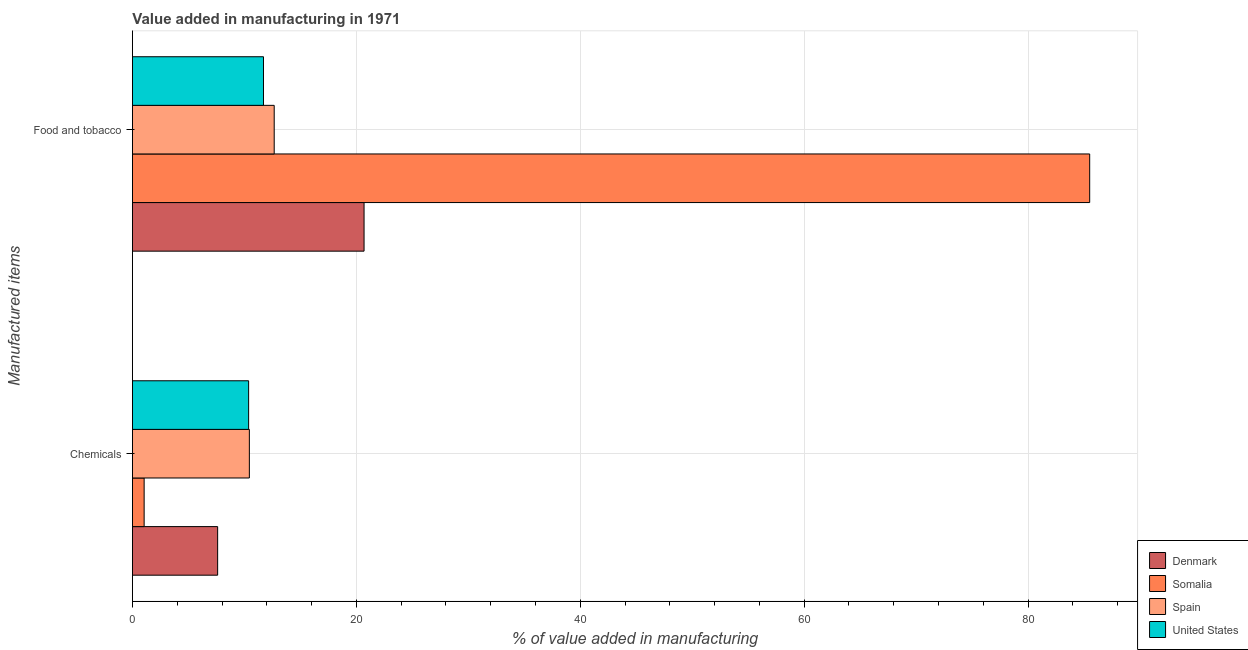Are the number of bars per tick equal to the number of legend labels?
Your answer should be very brief. Yes. Are the number of bars on each tick of the Y-axis equal?
Ensure brevity in your answer.  Yes. How many bars are there on the 1st tick from the bottom?
Offer a very short reply. 4. What is the label of the 2nd group of bars from the top?
Your answer should be very brief. Chemicals. What is the value added by manufacturing food and tobacco in Spain?
Offer a terse response. 12.66. Across all countries, what is the maximum value added by  manufacturing chemicals?
Keep it short and to the point. 10.44. Across all countries, what is the minimum value added by  manufacturing chemicals?
Your answer should be compact. 1.05. In which country was the value added by manufacturing food and tobacco maximum?
Make the answer very short. Somalia. In which country was the value added by  manufacturing chemicals minimum?
Offer a terse response. Somalia. What is the total value added by manufacturing food and tobacco in the graph?
Keep it short and to the point. 130.56. What is the difference between the value added by  manufacturing chemicals in Somalia and that in United States?
Provide a short and direct response. -9.33. What is the difference between the value added by manufacturing food and tobacco in Denmark and the value added by  manufacturing chemicals in Somalia?
Your response must be concise. 19.64. What is the average value added by  manufacturing chemicals per country?
Offer a very short reply. 7.37. What is the difference between the value added by manufacturing food and tobacco and value added by  manufacturing chemicals in Spain?
Your answer should be compact. 2.22. What is the ratio of the value added by manufacturing food and tobacco in Denmark to that in Somalia?
Make the answer very short. 0.24. In how many countries, is the value added by manufacturing food and tobacco greater than the average value added by manufacturing food and tobacco taken over all countries?
Keep it short and to the point. 1. What does the 3rd bar from the top in Food and tobacco represents?
Make the answer very short. Somalia. What does the 2nd bar from the bottom in Food and tobacco represents?
Provide a short and direct response. Somalia. Are all the bars in the graph horizontal?
Your answer should be compact. Yes. How many countries are there in the graph?
Ensure brevity in your answer.  4. What is the difference between two consecutive major ticks on the X-axis?
Provide a short and direct response. 20. Are the values on the major ticks of X-axis written in scientific E-notation?
Provide a succinct answer. No. Does the graph contain any zero values?
Your response must be concise. No. Does the graph contain grids?
Provide a succinct answer. Yes. Where does the legend appear in the graph?
Provide a short and direct response. Bottom right. How many legend labels are there?
Provide a succinct answer. 4. How are the legend labels stacked?
Your response must be concise. Vertical. What is the title of the graph?
Ensure brevity in your answer.  Value added in manufacturing in 1971. Does "Papua New Guinea" appear as one of the legend labels in the graph?
Make the answer very short. No. What is the label or title of the X-axis?
Your answer should be very brief. % of value added in manufacturing. What is the label or title of the Y-axis?
Keep it short and to the point. Manufactured items. What is the % of value added in manufacturing of Denmark in Chemicals?
Ensure brevity in your answer.  7.61. What is the % of value added in manufacturing of Somalia in Chemicals?
Provide a succinct answer. 1.05. What is the % of value added in manufacturing of Spain in Chemicals?
Your response must be concise. 10.44. What is the % of value added in manufacturing of United States in Chemicals?
Your answer should be very brief. 10.38. What is the % of value added in manufacturing in Denmark in Food and tobacco?
Your answer should be compact. 20.69. What is the % of value added in manufacturing in Somalia in Food and tobacco?
Give a very brief answer. 85.5. What is the % of value added in manufacturing in Spain in Food and tobacco?
Offer a terse response. 12.66. What is the % of value added in manufacturing in United States in Food and tobacco?
Give a very brief answer. 11.71. Across all Manufactured items, what is the maximum % of value added in manufacturing in Denmark?
Make the answer very short. 20.69. Across all Manufactured items, what is the maximum % of value added in manufacturing in Somalia?
Offer a terse response. 85.5. Across all Manufactured items, what is the maximum % of value added in manufacturing in Spain?
Give a very brief answer. 12.66. Across all Manufactured items, what is the maximum % of value added in manufacturing in United States?
Give a very brief answer. 11.71. Across all Manufactured items, what is the minimum % of value added in manufacturing in Denmark?
Provide a succinct answer. 7.61. Across all Manufactured items, what is the minimum % of value added in manufacturing of Somalia?
Your answer should be very brief. 1.05. Across all Manufactured items, what is the minimum % of value added in manufacturing in Spain?
Provide a succinct answer. 10.44. Across all Manufactured items, what is the minimum % of value added in manufacturing of United States?
Your answer should be compact. 10.38. What is the total % of value added in manufacturing in Denmark in the graph?
Give a very brief answer. 28.3. What is the total % of value added in manufacturing in Somalia in the graph?
Make the answer very short. 86.55. What is the total % of value added in manufacturing in Spain in the graph?
Provide a short and direct response. 23.11. What is the total % of value added in manufacturing of United States in the graph?
Your response must be concise. 22.08. What is the difference between the % of value added in manufacturing of Denmark in Chemicals and that in Food and tobacco?
Offer a terse response. -13.08. What is the difference between the % of value added in manufacturing of Somalia in Chemicals and that in Food and tobacco?
Provide a succinct answer. -84.46. What is the difference between the % of value added in manufacturing in Spain in Chemicals and that in Food and tobacco?
Ensure brevity in your answer.  -2.22. What is the difference between the % of value added in manufacturing in United States in Chemicals and that in Food and tobacco?
Offer a very short reply. -1.33. What is the difference between the % of value added in manufacturing in Denmark in Chemicals and the % of value added in manufacturing in Somalia in Food and tobacco?
Your answer should be very brief. -77.89. What is the difference between the % of value added in manufacturing in Denmark in Chemicals and the % of value added in manufacturing in Spain in Food and tobacco?
Give a very brief answer. -5.05. What is the difference between the % of value added in manufacturing in Denmark in Chemicals and the % of value added in manufacturing in United States in Food and tobacco?
Provide a short and direct response. -4.1. What is the difference between the % of value added in manufacturing of Somalia in Chemicals and the % of value added in manufacturing of Spain in Food and tobacco?
Offer a terse response. -11.62. What is the difference between the % of value added in manufacturing in Somalia in Chemicals and the % of value added in manufacturing in United States in Food and tobacco?
Your response must be concise. -10.66. What is the difference between the % of value added in manufacturing in Spain in Chemicals and the % of value added in manufacturing in United States in Food and tobacco?
Your answer should be very brief. -1.26. What is the average % of value added in manufacturing of Denmark per Manufactured items?
Offer a very short reply. 14.15. What is the average % of value added in manufacturing of Somalia per Manufactured items?
Make the answer very short. 43.27. What is the average % of value added in manufacturing of Spain per Manufactured items?
Keep it short and to the point. 11.55. What is the average % of value added in manufacturing in United States per Manufactured items?
Keep it short and to the point. 11.04. What is the difference between the % of value added in manufacturing of Denmark and % of value added in manufacturing of Somalia in Chemicals?
Your answer should be very brief. 6.56. What is the difference between the % of value added in manufacturing of Denmark and % of value added in manufacturing of Spain in Chemicals?
Provide a succinct answer. -2.83. What is the difference between the % of value added in manufacturing in Denmark and % of value added in manufacturing in United States in Chemicals?
Provide a short and direct response. -2.77. What is the difference between the % of value added in manufacturing in Somalia and % of value added in manufacturing in Spain in Chemicals?
Your response must be concise. -9.4. What is the difference between the % of value added in manufacturing of Somalia and % of value added in manufacturing of United States in Chemicals?
Your response must be concise. -9.33. What is the difference between the % of value added in manufacturing in Spain and % of value added in manufacturing in United States in Chemicals?
Your answer should be very brief. 0.07. What is the difference between the % of value added in manufacturing of Denmark and % of value added in manufacturing of Somalia in Food and tobacco?
Your answer should be compact. -64.81. What is the difference between the % of value added in manufacturing in Denmark and % of value added in manufacturing in Spain in Food and tobacco?
Your response must be concise. 8.03. What is the difference between the % of value added in manufacturing in Denmark and % of value added in manufacturing in United States in Food and tobacco?
Offer a terse response. 8.98. What is the difference between the % of value added in manufacturing of Somalia and % of value added in manufacturing of Spain in Food and tobacco?
Provide a short and direct response. 72.84. What is the difference between the % of value added in manufacturing of Somalia and % of value added in manufacturing of United States in Food and tobacco?
Provide a succinct answer. 73.79. What is the difference between the % of value added in manufacturing of Spain and % of value added in manufacturing of United States in Food and tobacco?
Keep it short and to the point. 0.96. What is the ratio of the % of value added in manufacturing in Denmark in Chemicals to that in Food and tobacco?
Offer a terse response. 0.37. What is the ratio of the % of value added in manufacturing of Somalia in Chemicals to that in Food and tobacco?
Ensure brevity in your answer.  0.01. What is the ratio of the % of value added in manufacturing in Spain in Chemicals to that in Food and tobacco?
Ensure brevity in your answer.  0.82. What is the ratio of the % of value added in manufacturing of United States in Chemicals to that in Food and tobacco?
Keep it short and to the point. 0.89. What is the difference between the highest and the second highest % of value added in manufacturing of Denmark?
Ensure brevity in your answer.  13.08. What is the difference between the highest and the second highest % of value added in manufacturing of Somalia?
Make the answer very short. 84.46. What is the difference between the highest and the second highest % of value added in manufacturing in Spain?
Keep it short and to the point. 2.22. What is the difference between the highest and the second highest % of value added in manufacturing in United States?
Give a very brief answer. 1.33. What is the difference between the highest and the lowest % of value added in manufacturing in Denmark?
Keep it short and to the point. 13.08. What is the difference between the highest and the lowest % of value added in manufacturing in Somalia?
Your answer should be compact. 84.46. What is the difference between the highest and the lowest % of value added in manufacturing of Spain?
Your answer should be very brief. 2.22. What is the difference between the highest and the lowest % of value added in manufacturing in United States?
Your response must be concise. 1.33. 